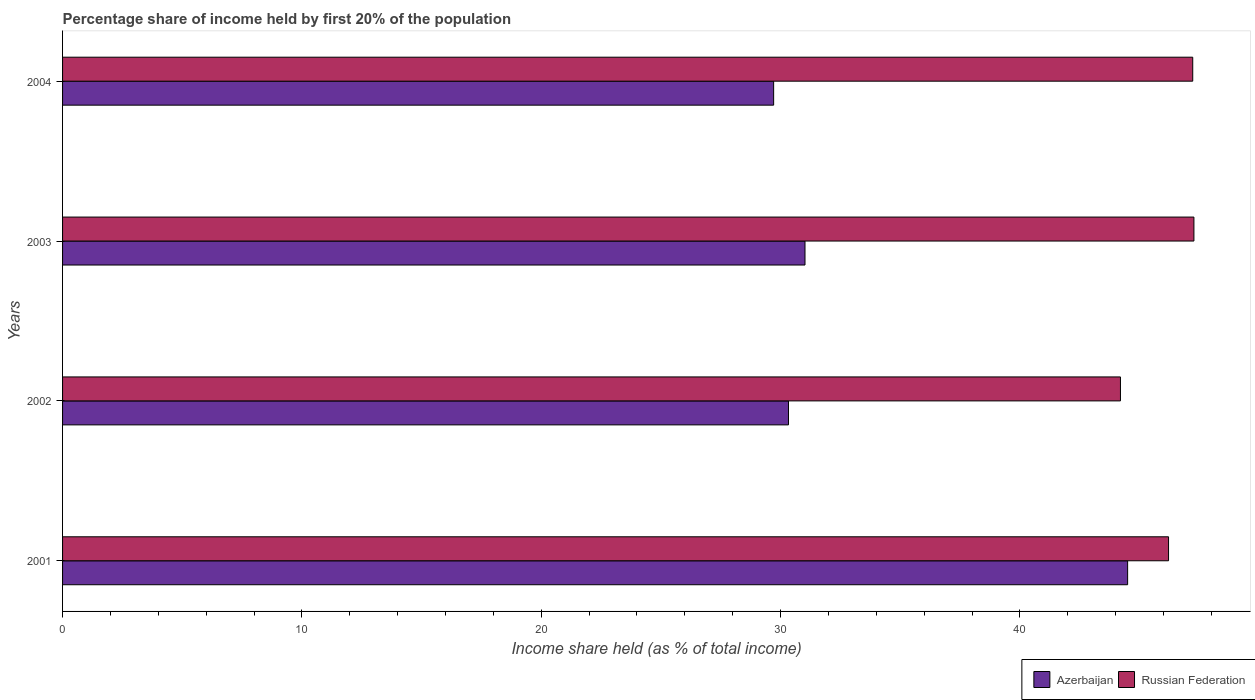How many different coloured bars are there?
Your response must be concise. 2. How many groups of bars are there?
Make the answer very short. 4. Are the number of bars on each tick of the Y-axis equal?
Make the answer very short. Yes. How many bars are there on the 3rd tick from the top?
Your answer should be very brief. 2. What is the label of the 4th group of bars from the top?
Keep it short and to the point. 2001. In how many cases, is the number of bars for a given year not equal to the number of legend labels?
Offer a terse response. 0. What is the share of income held by first 20% of the population in Azerbaijan in 2001?
Ensure brevity in your answer.  44.5. Across all years, what is the maximum share of income held by first 20% of the population in Russian Federation?
Your response must be concise. 47.27. Across all years, what is the minimum share of income held by first 20% of the population in Russian Federation?
Provide a short and direct response. 44.2. In which year was the share of income held by first 20% of the population in Russian Federation maximum?
Provide a succinct answer. 2003. In which year was the share of income held by first 20% of the population in Azerbaijan minimum?
Give a very brief answer. 2004. What is the total share of income held by first 20% of the population in Russian Federation in the graph?
Your answer should be compact. 184.9. What is the difference between the share of income held by first 20% of the population in Azerbaijan in 2001 and that in 2004?
Provide a succinct answer. 14.79. What is the difference between the share of income held by first 20% of the population in Azerbaijan in 2004 and the share of income held by first 20% of the population in Russian Federation in 2002?
Your answer should be very brief. -14.49. What is the average share of income held by first 20% of the population in Azerbaijan per year?
Ensure brevity in your answer.  33.89. In the year 2004, what is the difference between the share of income held by first 20% of the population in Russian Federation and share of income held by first 20% of the population in Azerbaijan?
Offer a very short reply. 17.51. In how many years, is the share of income held by first 20% of the population in Azerbaijan greater than 44 %?
Ensure brevity in your answer.  1. What is the ratio of the share of income held by first 20% of the population in Russian Federation in 2003 to that in 2004?
Offer a very short reply. 1. What is the difference between the highest and the second highest share of income held by first 20% of the population in Azerbaijan?
Your response must be concise. 13.48. What is the difference between the highest and the lowest share of income held by first 20% of the population in Azerbaijan?
Provide a succinct answer. 14.79. Is the sum of the share of income held by first 20% of the population in Russian Federation in 2001 and 2003 greater than the maximum share of income held by first 20% of the population in Azerbaijan across all years?
Your response must be concise. Yes. What does the 1st bar from the top in 2004 represents?
Make the answer very short. Russian Federation. What does the 1st bar from the bottom in 2003 represents?
Make the answer very short. Azerbaijan. How many bars are there?
Your answer should be very brief. 8. Are all the bars in the graph horizontal?
Your answer should be very brief. Yes. Are the values on the major ticks of X-axis written in scientific E-notation?
Provide a short and direct response. No. Where does the legend appear in the graph?
Offer a very short reply. Bottom right. How many legend labels are there?
Offer a terse response. 2. What is the title of the graph?
Your response must be concise. Percentage share of income held by first 20% of the population. Does "East Asia (developing only)" appear as one of the legend labels in the graph?
Offer a terse response. No. What is the label or title of the X-axis?
Provide a short and direct response. Income share held (as % of total income). What is the label or title of the Y-axis?
Provide a succinct answer. Years. What is the Income share held (as % of total income) of Azerbaijan in 2001?
Your response must be concise. 44.5. What is the Income share held (as % of total income) of Russian Federation in 2001?
Offer a terse response. 46.21. What is the Income share held (as % of total income) in Azerbaijan in 2002?
Your answer should be very brief. 30.33. What is the Income share held (as % of total income) of Russian Federation in 2002?
Your response must be concise. 44.2. What is the Income share held (as % of total income) in Azerbaijan in 2003?
Make the answer very short. 31.02. What is the Income share held (as % of total income) of Russian Federation in 2003?
Provide a succinct answer. 47.27. What is the Income share held (as % of total income) in Azerbaijan in 2004?
Provide a succinct answer. 29.71. What is the Income share held (as % of total income) in Russian Federation in 2004?
Offer a terse response. 47.22. Across all years, what is the maximum Income share held (as % of total income) in Azerbaijan?
Your answer should be very brief. 44.5. Across all years, what is the maximum Income share held (as % of total income) in Russian Federation?
Make the answer very short. 47.27. Across all years, what is the minimum Income share held (as % of total income) of Azerbaijan?
Provide a succinct answer. 29.71. Across all years, what is the minimum Income share held (as % of total income) in Russian Federation?
Offer a very short reply. 44.2. What is the total Income share held (as % of total income) in Azerbaijan in the graph?
Make the answer very short. 135.56. What is the total Income share held (as % of total income) of Russian Federation in the graph?
Offer a very short reply. 184.9. What is the difference between the Income share held (as % of total income) of Azerbaijan in 2001 and that in 2002?
Your answer should be very brief. 14.17. What is the difference between the Income share held (as % of total income) of Russian Federation in 2001 and that in 2002?
Provide a succinct answer. 2.01. What is the difference between the Income share held (as % of total income) in Azerbaijan in 2001 and that in 2003?
Ensure brevity in your answer.  13.48. What is the difference between the Income share held (as % of total income) in Russian Federation in 2001 and that in 2003?
Your response must be concise. -1.06. What is the difference between the Income share held (as % of total income) in Azerbaijan in 2001 and that in 2004?
Ensure brevity in your answer.  14.79. What is the difference between the Income share held (as % of total income) in Russian Federation in 2001 and that in 2004?
Your answer should be compact. -1.01. What is the difference between the Income share held (as % of total income) in Azerbaijan in 2002 and that in 2003?
Your answer should be compact. -0.69. What is the difference between the Income share held (as % of total income) in Russian Federation in 2002 and that in 2003?
Your answer should be very brief. -3.07. What is the difference between the Income share held (as % of total income) of Azerbaijan in 2002 and that in 2004?
Your answer should be compact. 0.62. What is the difference between the Income share held (as % of total income) of Russian Federation in 2002 and that in 2004?
Your response must be concise. -3.02. What is the difference between the Income share held (as % of total income) in Azerbaijan in 2003 and that in 2004?
Offer a very short reply. 1.31. What is the difference between the Income share held (as % of total income) of Russian Federation in 2003 and that in 2004?
Your answer should be very brief. 0.05. What is the difference between the Income share held (as % of total income) of Azerbaijan in 2001 and the Income share held (as % of total income) of Russian Federation in 2003?
Your answer should be compact. -2.77. What is the difference between the Income share held (as % of total income) in Azerbaijan in 2001 and the Income share held (as % of total income) in Russian Federation in 2004?
Your answer should be compact. -2.72. What is the difference between the Income share held (as % of total income) of Azerbaijan in 2002 and the Income share held (as % of total income) of Russian Federation in 2003?
Your answer should be very brief. -16.94. What is the difference between the Income share held (as % of total income) of Azerbaijan in 2002 and the Income share held (as % of total income) of Russian Federation in 2004?
Offer a very short reply. -16.89. What is the difference between the Income share held (as % of total income) of Azerbaijan in 2003 and the Income share held (as % of total income) of Russian Federation in 2004?
Provide a succinct answer. -16.2. What is the average Income share held (as % of total income) in Azerbaijan per year?
Provide a short and direct response. 33.89. What is the average Income share held (as % of total income) of Russian Federation per year?
Keep it short and to the point. 46.23. In the year 2001, what is the difference between the Income share held (as % of total income) of Azerbaijan and Income share held (as % of total income) of Russian Federation?
Your answer should be compact. -1.71. In the year 2002, what is the difference between the Income share held (as % of total income) of Azerbaijan and Income share held (as % of total income) of Russian Federation?
Give a very brief answer. -13.87. In the year 2003, what is the difference between the Income share held (as % of total income) in Azerbaijan and Income share held (as % of total income) in Russian Federation?
Give a very brief answer. -16.25. In the year 2004, what is the difference between the Income share held (as % of total income) in Azerbaijan and Income share held (as % of total income) in Russian Federation?
Offer a very short reply. -17.51. What is the ratio of the Income share held (as % of total income) in Azerbaijan in 2001 to that in 2002?
Provide a succinct answer. 1.47. What is the ratio of the Income share held (as % of total income) in Russian Federation in 2001 to that in 2002?
Provide a succinct answer. 1.05. What is the ratio of the Income share held (as % of total income) of Azerbaijan in 2001 to that in 2003?
Provide a short and direct response. 1.43. What is the ratio of the Income share held (as % of total income) in Russian Federation in 2001 to that in 2003?
Provide a short and direct response. 0.98. What is the ratio of the Income share held (as % of total income) in Azerbaijan in 2001 to that in 2004?
Offer a terse response. 1.5. What is the ratio of the Income share held (as % of total income) of Russian Federation in 2001 to that in 2004?
Your response must be concise. 0.98. What is the ratio of the Income share held (as % of total income) in Azerbaijan in 2002 to that in 2003?
Your answer should be very brief. 0.98. What is the ratio of the Income share held (as % of total income) of Russian Federation in 2002 to that in 2003?
Make the answer very short. 0.94. What is the ratio of the Income share held (as % of total income) of Azerbaijan in 2002 to that in 2004?
Make the answer very short. 1.02. What is the ratio of the Income share held (as % of total income) of Russian Federation in 2002 to that in 2004?
Provide a succinct answer. 0.94. What is the ratio of the Income share held (as % of total income) in Azerbaijan in 2003 to that in 2004?
Your answer should be compact. 1.04. What is the ratio of the Income share held (as % of total income) of Russian Federation in 2003 to that in 2004?
Provide a succinct answer. 1. What is the difference between the highest and the second highest Income share held (as % of total income) of Azerbaijan?
Make the answer very short. 13.48. What is the difference between the highest and the second highest Income share held (as % of total income) of Russian Federation?
Your answer should be compact. 0.05. What is the difference between the highest and the lowest Income share held (as % of total income) in Azerbaijan?
Provide a short and direct response. 14.79. What is the difference between the highest and the lowest Income share held (as % of total income) of Russian Federation?
Give a very brief answer. 3.07. 